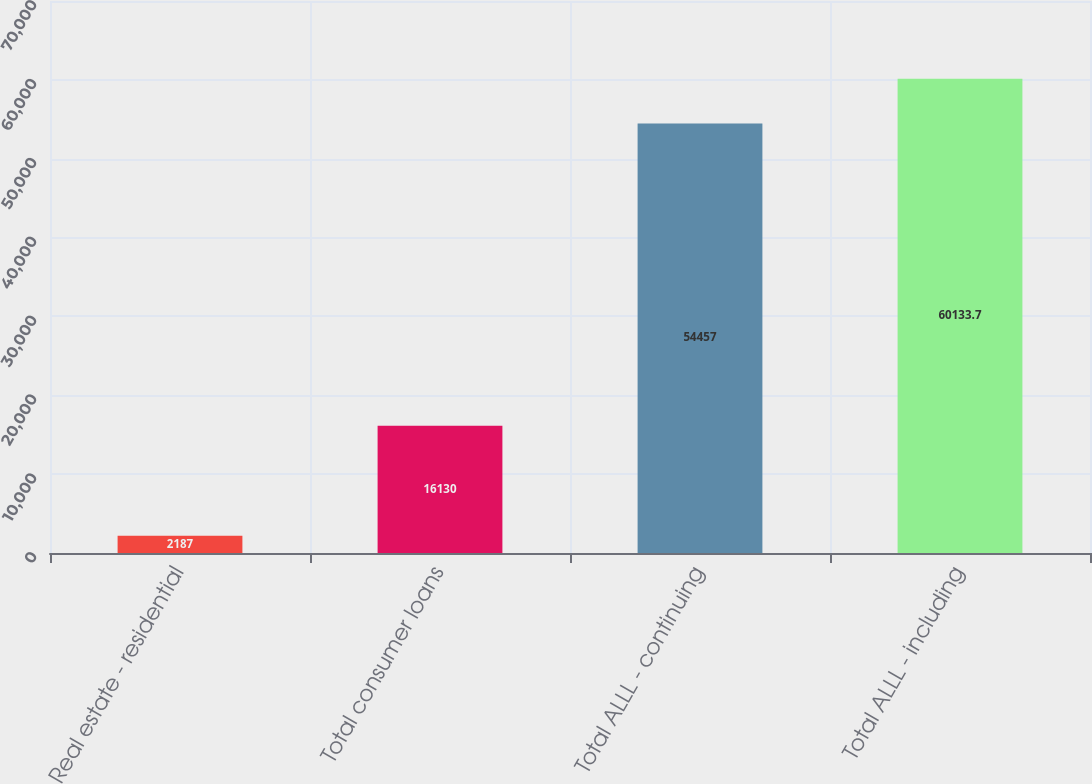<chart> <loc_0><loc_0><loc_500><loc_500><bar_chart><fcel>Real estate - residential<fcel>Total consumer loans<fcel>Total ALLL - continuing<fcel>Total ALLL - including<nl><fcel>2187<fcel>16130<fcel>54457<fcel>60133.7<nl></chart> 